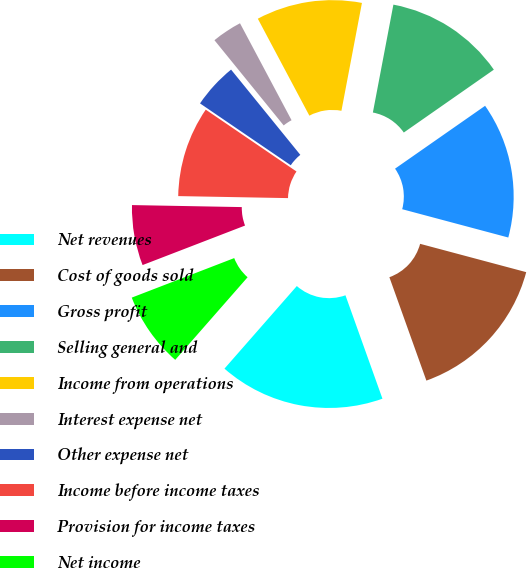Convert chart. <chart><loc_0><loc_0><loc_500><loc_500><pie_chart><fcel>Net revenues<fcel>Cost of goods sold<fcel>Gross profit<fcel>Selling general and<fcel>Income from operations<fcel>Interest expense net<fcel>Other expense net<fcel>Income before income taxes<fcel>Provision for income taxes<fcel>Net income<nl><fcel>16.92%<fcel>15.38%<fcel>13.85%<fcel>12.31%<fcel>10.77%<fcel>3.08%<fcel>4.62%<fcel>9.23%<fcel>6.15%<fcel>7.69%<nl></chart> 